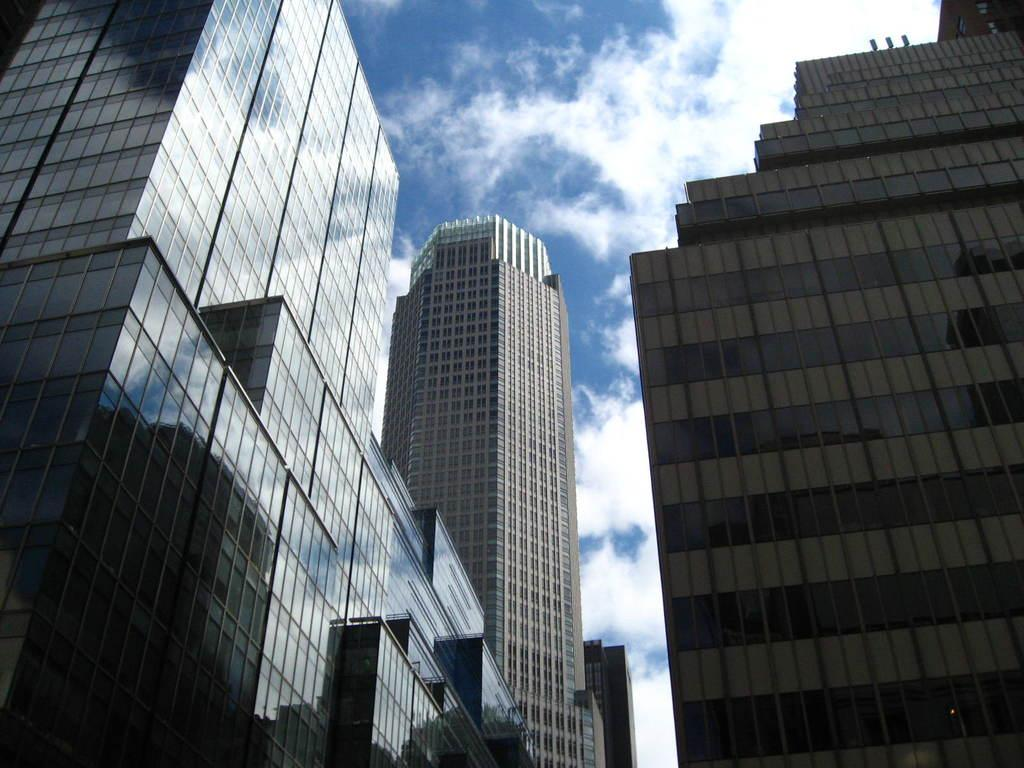What type of structures can be seen in the image? There are buildings in the image. What can be seen in the sky in the background of the image? There are clouds in the sky in the background of the image. What force is being applied to the door in the image? There is no door present in the image, so no force is being applied to a door. 